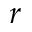<formula> <loc_0><loc_0><loc_500><loc_500>r</formula> 